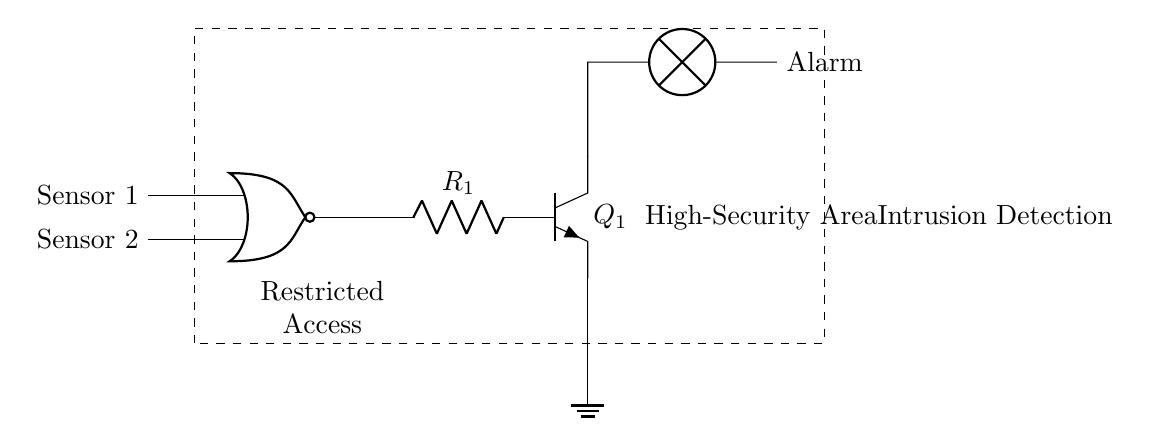What type of gate is used in this circuit? The circuit uses a NOR gate, which is indicated by the specific symbol labeled as "nor port."
Answer: NOR gate How many sensors are connected to the gate? There are two sensors connected to the NOR gate, as there are two input lines labeled “Sensor 1” and “Sensor 2.”
Answer: Two What does the output of the NOR gate control? The output of the NOR gate controls a transistor labeled "Q1," which, in turn, drives an alarm light.
Answer: Alarm What is the component connected after the NOR gate in this circuit? A resistor labeled "R1" is connected after the output of the NOR gate, leading to the transistor.
Answer: Resistor If both sensors are triggered, what will be the output of the NOR gate? If both sensors are triggered, the output of the NOR gate will be low (0), since a NOR gate outputs high only when both inputs are low.
Answer: Low What area does this circuit monitor? The circuit monitors a “High-Security Area,” which is indicated in the label on the right side of the diagram.
Answer: High-Security Area What type of device is indicated by the symbol connected to the transistor? The symbol connected to the transistor represents a lamp, which serves as an alarm in this circuit.
Answer: Lamp 